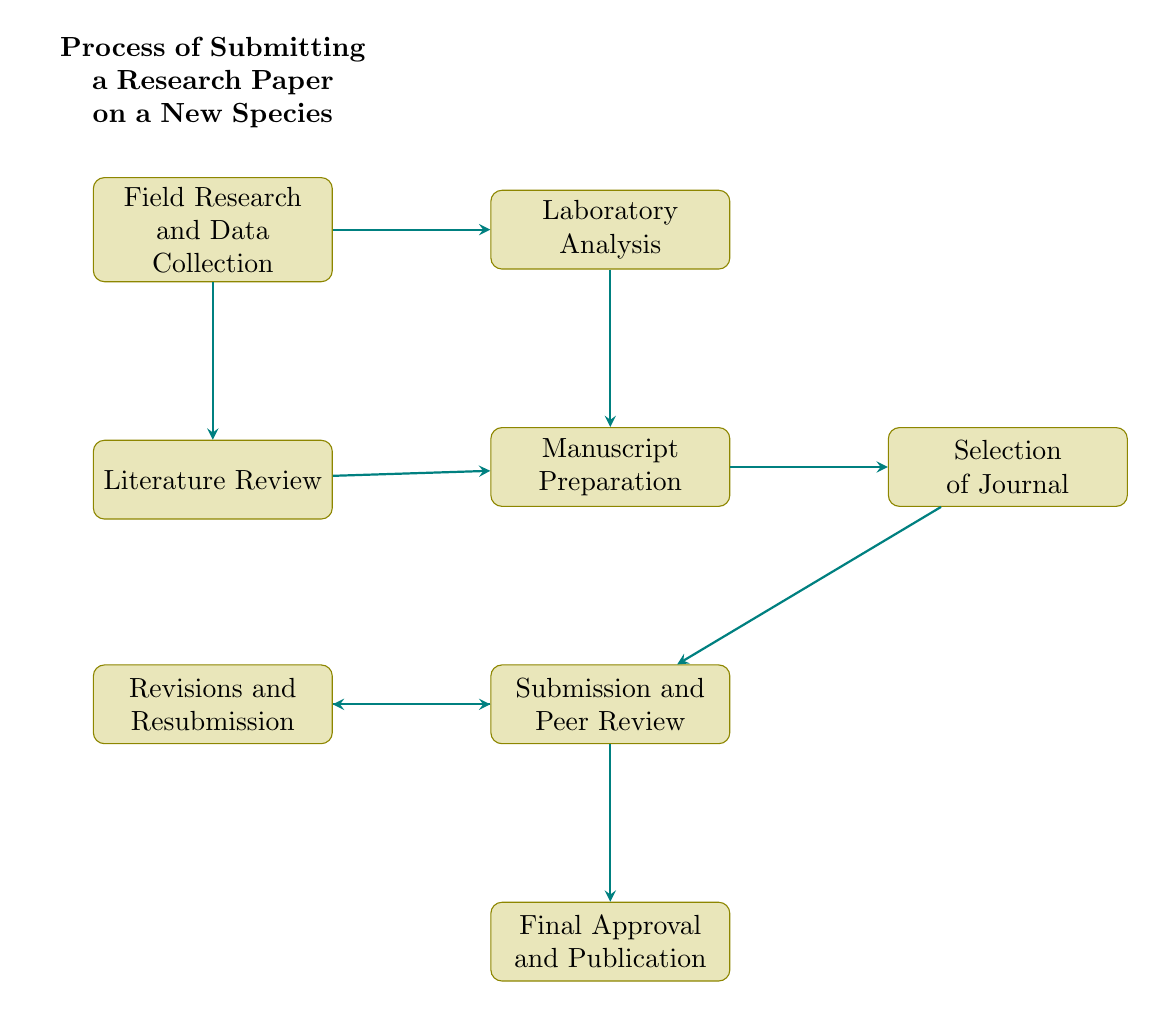What is the first step in the process? The process starts with "Field Research and Data Collection," which is the first node in the flow chart.
Answer: Field Research and Data Collection How many nodes are there in this flow chart? By counting each process represented as a node, there are a total of eight nodes in the flow chart.
Answer: 8 What follows "Literature Review"? The next process that follows "Literature Review" is "Manuscript Preparation," which is the node that comes directly after it.
Answer: Manuscript Preparation Which node leads to "Final Approval and Publication"? The node "Submission and Peer Review" leads directly to "Final Approval and Publication," as indicated by the arrow connecting these two nodes.
Answer: Submission and Peer Review What is the relationship between "Manuscript Preparation" and "Selection of Journal"? "Manuscript Preparation" precedes "Selection of Journal," meaning it must be completed before selecting a journal to submit to.
Answer: Precedes Explain the significance of the "Revisions and Resubmission" node in the process. The "Revisions and Resubmission" node is crucial as it represents the steps taken to address feedback from reviewers, indicating that submission might not be final and requires adjustments. It connects back to "Submission and Peer Review," showing an iterative process.
Answer: Iterative Process What are the two processes that lead into "Manuscript Preparation"? "Laboratory Analysis" and "Literature Review" both lead into "Manuscript Preparation," indicating that data from both processes are needed for writing the manuscript.
Answer: Laboratory Analysis and Literature Review Which step comes after "Selection of Journal"? The step that follows "Selection of Journal" is "Submission and Peer Review," which is the next action taken after selecting a suitable journal for publication.
Answer: Submission and Peer Review 